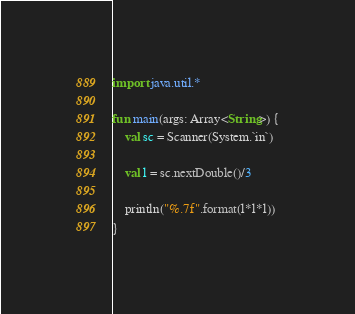<code> <loc_0><loc_0><loc_500><loc_500><_Kotlin_>import java.util.*

fun main(args: Array<String>) {
    val sc = Scanner(System.`in`)

    val l = sc.nextDouble()/3

    println("%.7f".format(l*l*l))
}</code> 